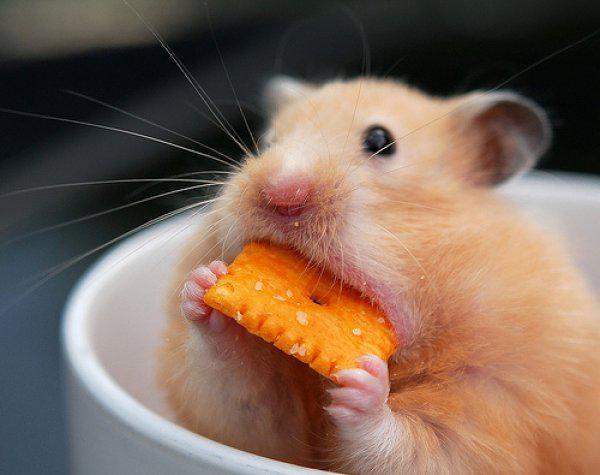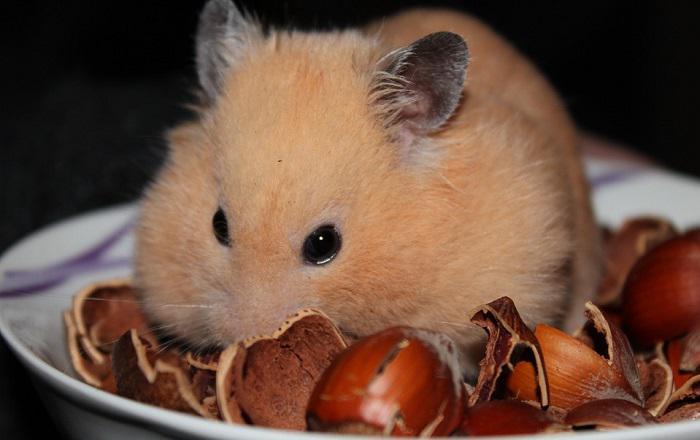The first image is the image on the left, the second image is the image on the right. For the images displayed, is the sentence "An image shows a pet rodent holding an orange food item in both front paws." factually correct? Answer yes or no. Yes. The first image is the image on the left, the second image is the image on the right. For the images shown, is this caption "The rodent is sitting in its food in one of the images." true? Answer yes or no. Yes. 